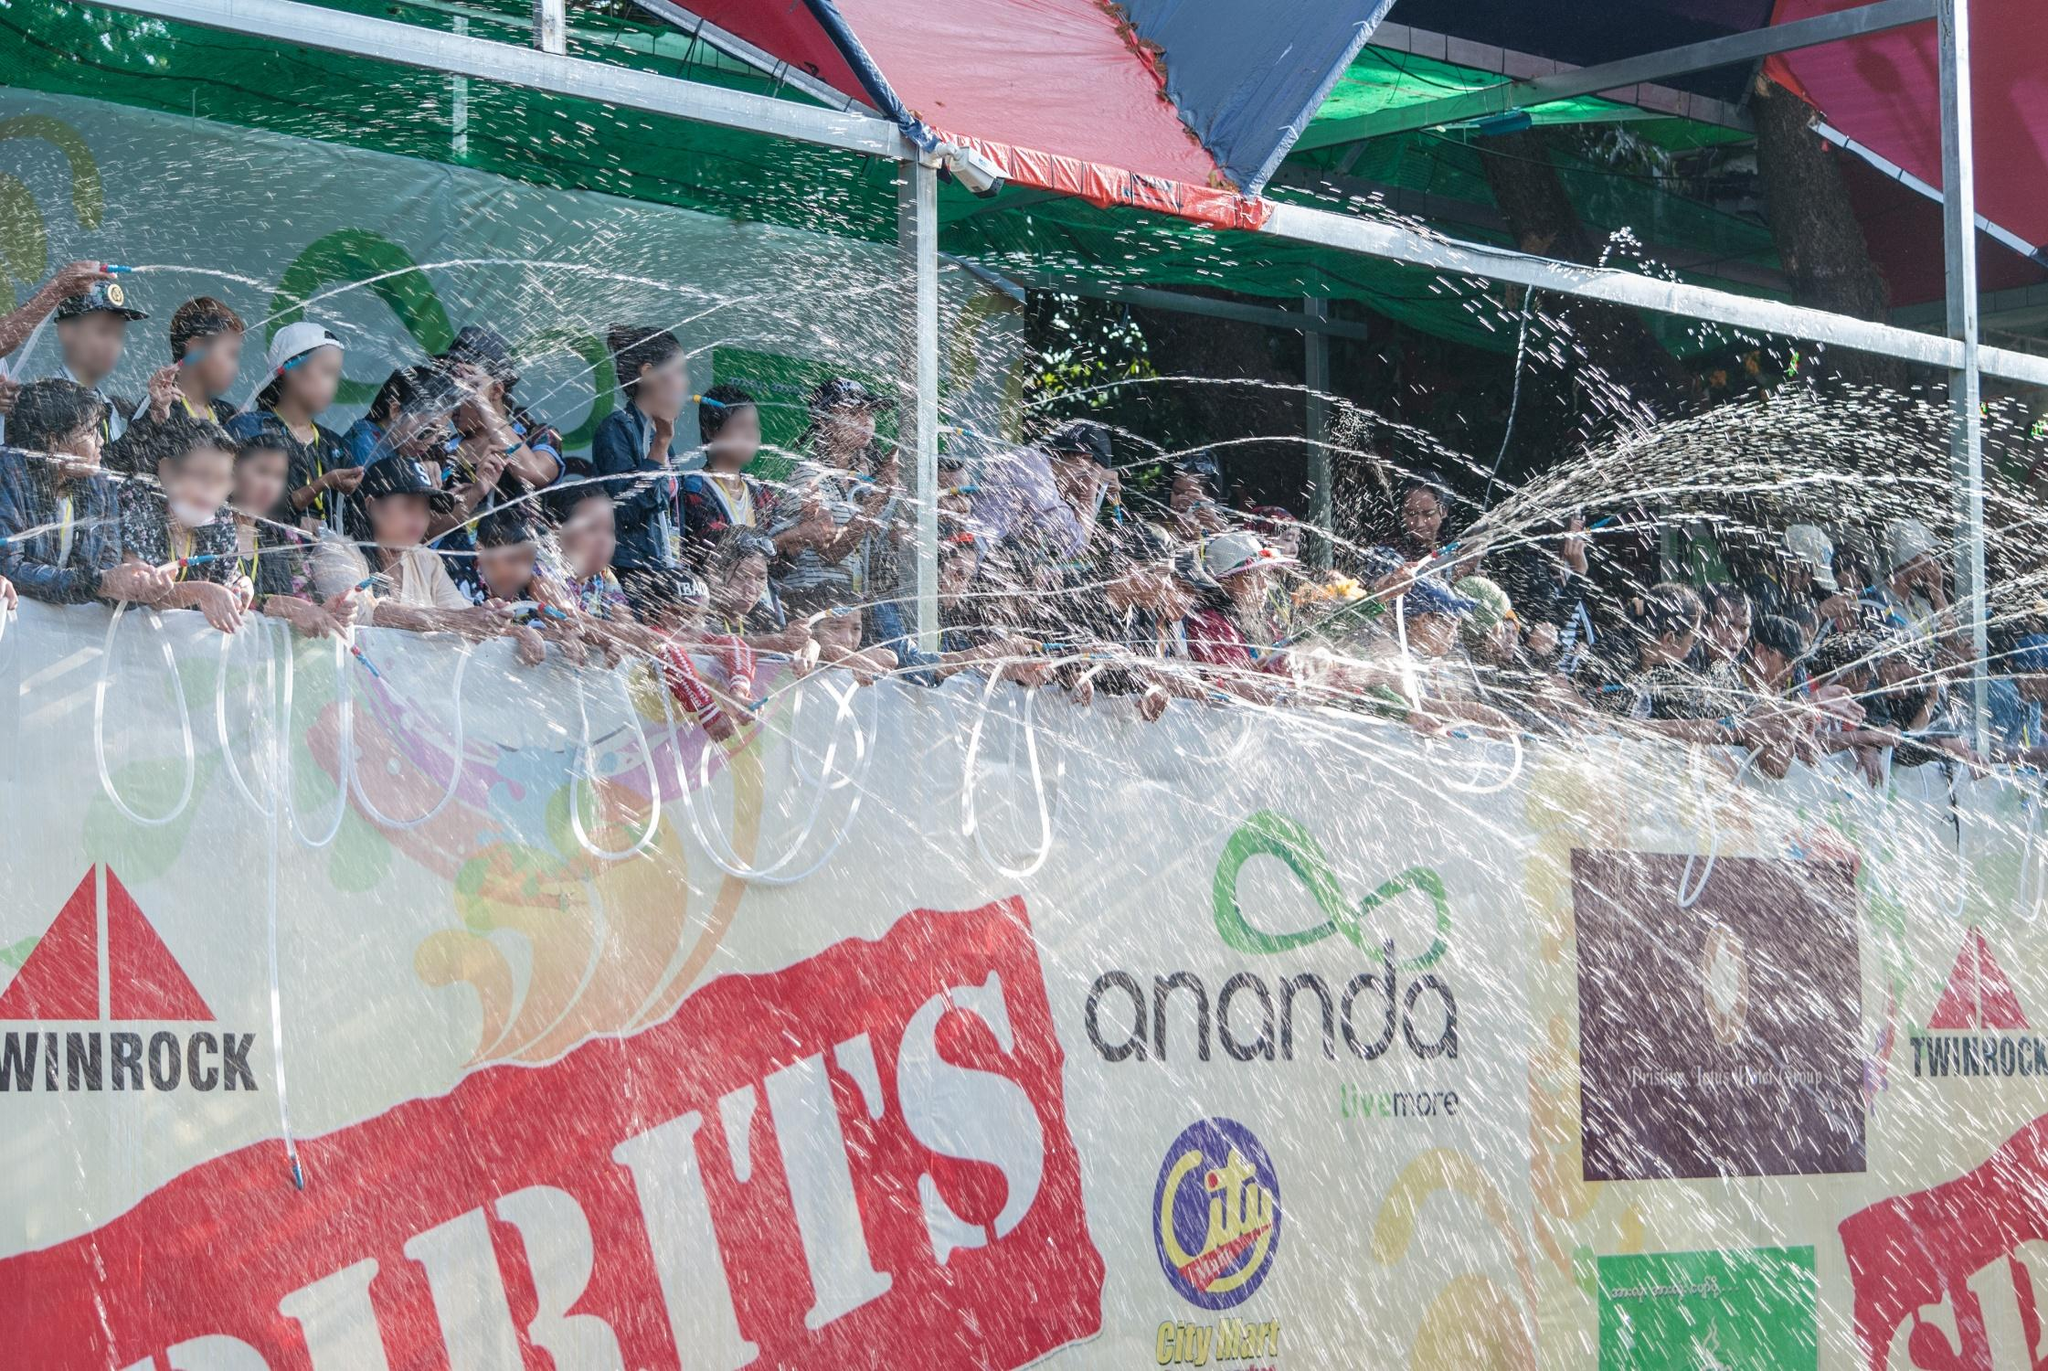Describe a realistic scenario where this water fight might happen. This kind of water fight is a common sight during the Songkran festival in Thailand, which marks the traditional Thai New Year. During Songkran, people take to the streets armed with buckets, water guns, and hoses, engaging in good-natured water fights with friends, neighbors, and even strangers. The float in the image could be part of a larger parade celebrating the festival, with participants on the float using hoses to spray water into the crowd, who eagerly return the favor. It's a time of joyous revelry, where the streets are filled with laughter, music, and the delighted screams of people as they get drenched. For a brief period, the normal routine of life is set aside for a communal celebration of renewal and good fortune. 